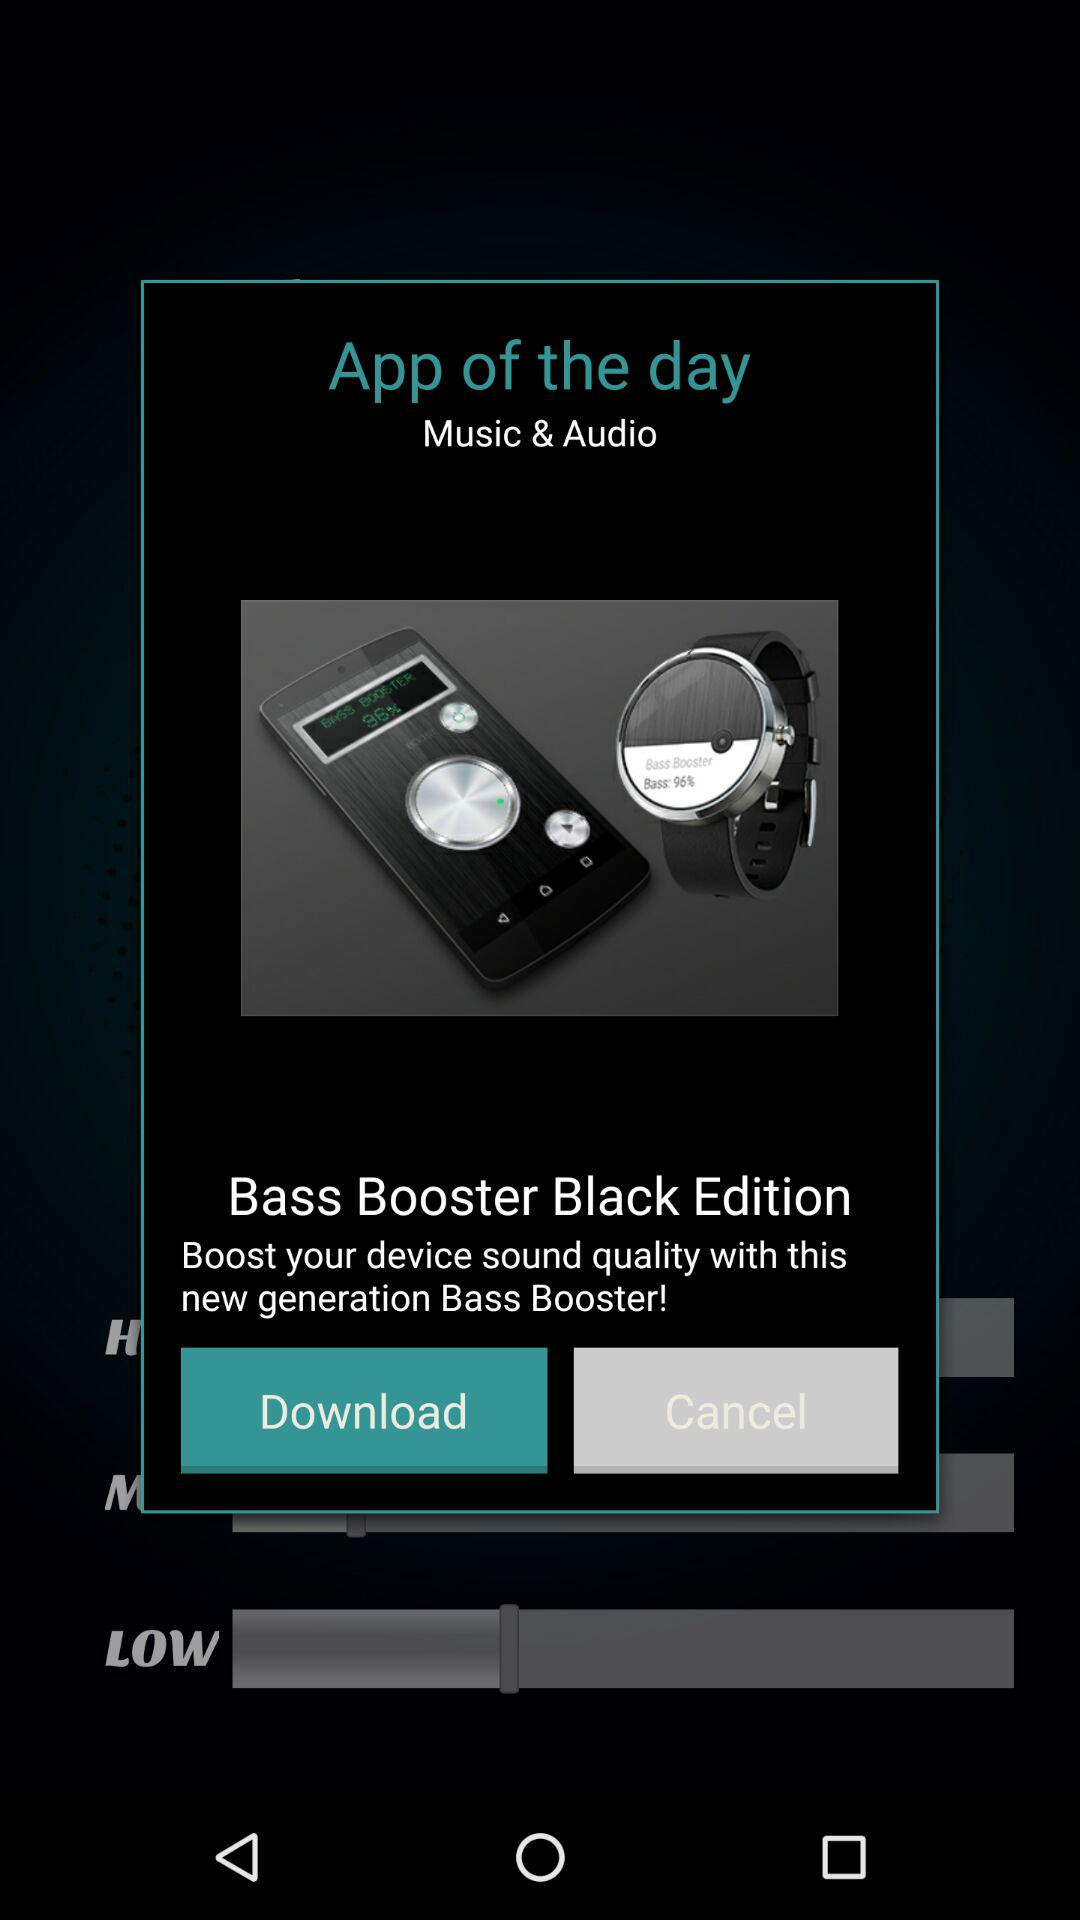What is the application name? The application name is "Bass Booster Black Edition". 